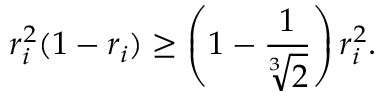<formula> <loc_0><loc_0><loc_500><loc_500>r _ { i } ^ { 2 } ( 1 - r _ { i } ) \geq \left ( 1 - \frac { 1 } { \sqrt { [ } 3 ] { 2 } } \right ) r _ { i } ^ { 2 } .</formula> 